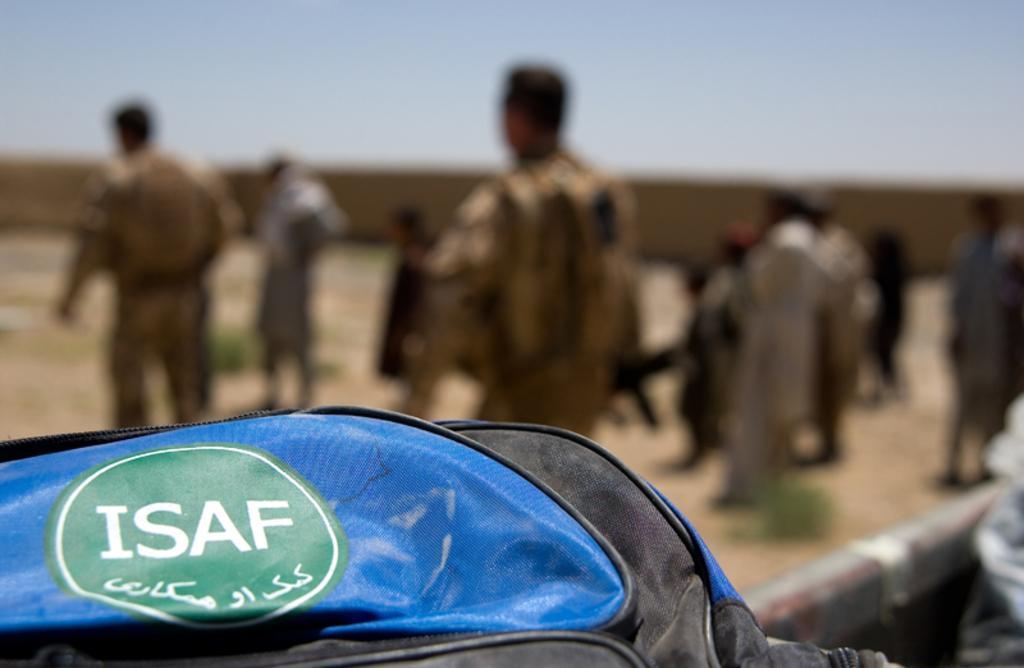What type of bag is in the image? There is a blue color bag in the image. Can you describe the people in the image? The facts provided do not give specific details about the people in the image. What is the condition of the background in the image? The background of the image is blurred. What is visible at the top of the image? The sky is visible at the top of the image. How many mice are sitting on the clock in the image? There are no mice or clocks present in the image. What decisions is the committee making in the image? There is no committee or decision-making process depicted in the image. 